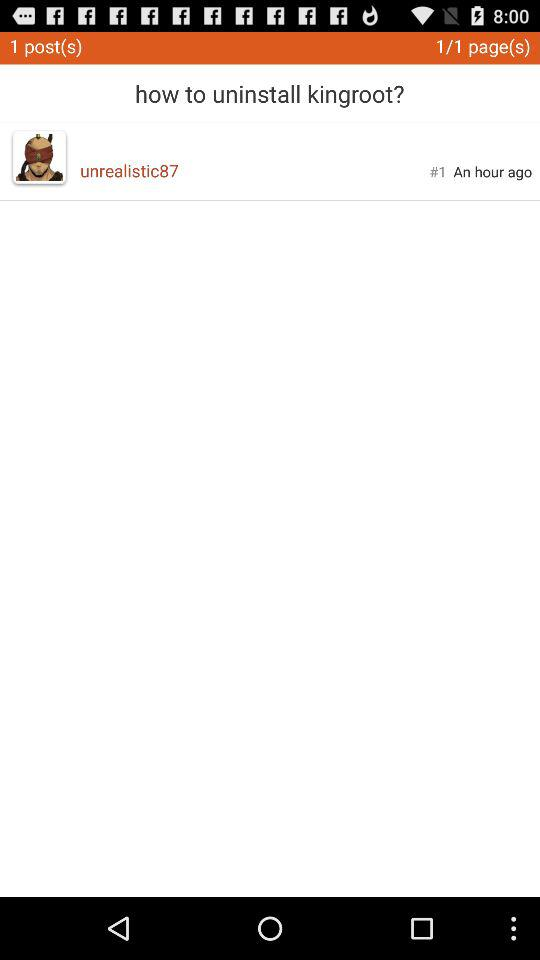What is the name of the application?
When the provided information is insufficient, respond with <no answer>. <no answer> 